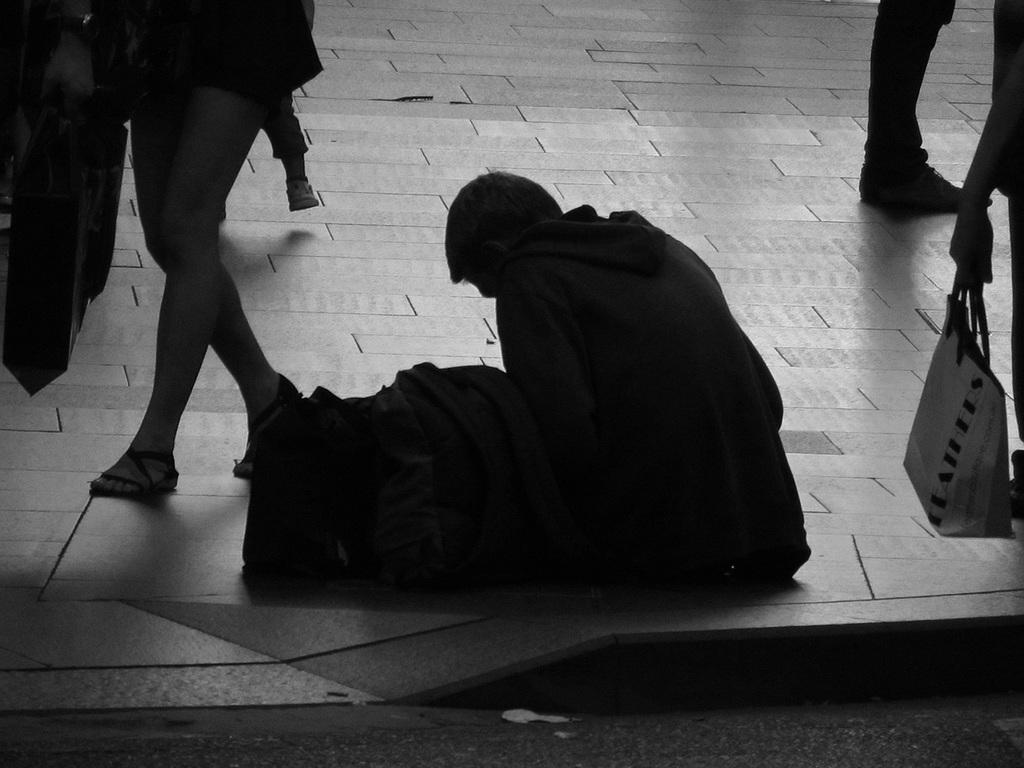What are the people in the image doing? The people in the image are walking. What are the people holding in their hands? The people are holding bags in their hands. Can you describe the seated person in the image? There is a human seated in the image. What else can be seen on the floor in the image? There are bags on the floor in the image. What type of creature is hiding behind the bags on the floor? There is no creature present in the image; it only features people walking and holding bags, as well as a seated person. 